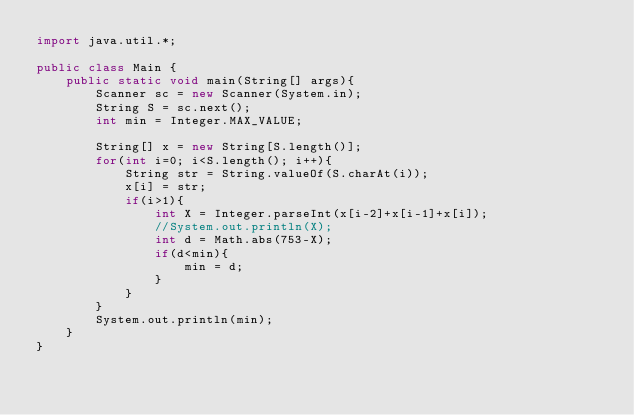<code> <loc_0><loc_0><loc_500><loc_500><_Java_>import java.util.*;
 
public class Main {
 	public static void main(String[] args){
    	Scanner sc = new Scanner(System.in);
		String S = sc.next();
		int min = Integer.MAX_VALUE;
 
		String[] x = new String[S.length()];
		for(int i=0; i<S.length(); i++){
			String str = String.valueOf(S.charAt(i));
			x[i] = str;
			if(i>1){
				int X = Integer.parseInt(x[i-2]+x[i-1]+x[i]);
				//System.out.println(X);
				int d = Math.abs(753-X);
				if(d<min){
					min = d;
				}
			}
		}
		System.out.println(min);
	}
}</code> 